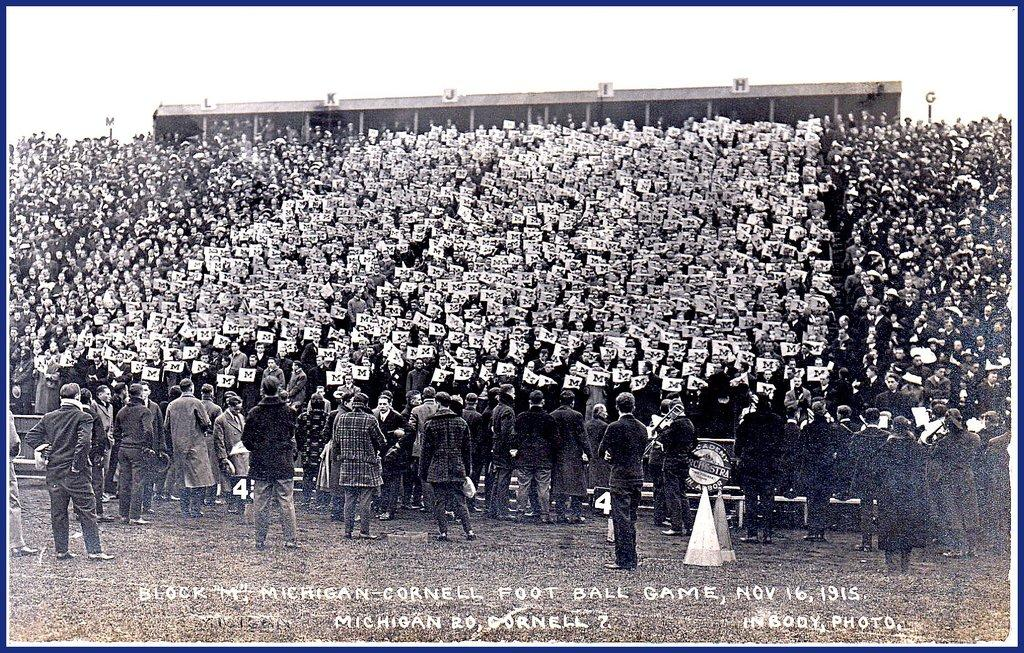What is the main subject of the image? The main subject of the image is a group of people. What are some of the people holding in the image? Some people in the image are holding boards. What color scheme is used in the image? The image is in black and white. How many hats can be seen on the people in the image? There are no hats visible in the image; the focus is on the people holding boards. 